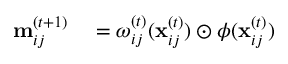<formula> <loc_0><loc_0><loc_500><loc_500>\begin{array} { r l } { m _ { i j } ^ { ( t + 1 ) } } & = \omega _ { i j } ^ { ( t ) } ( x _ { i j } ^ { ( t ) } ) \odot \phi ( x _ { i j } ^ { ( t ) } ) } \end{array}</formula> 